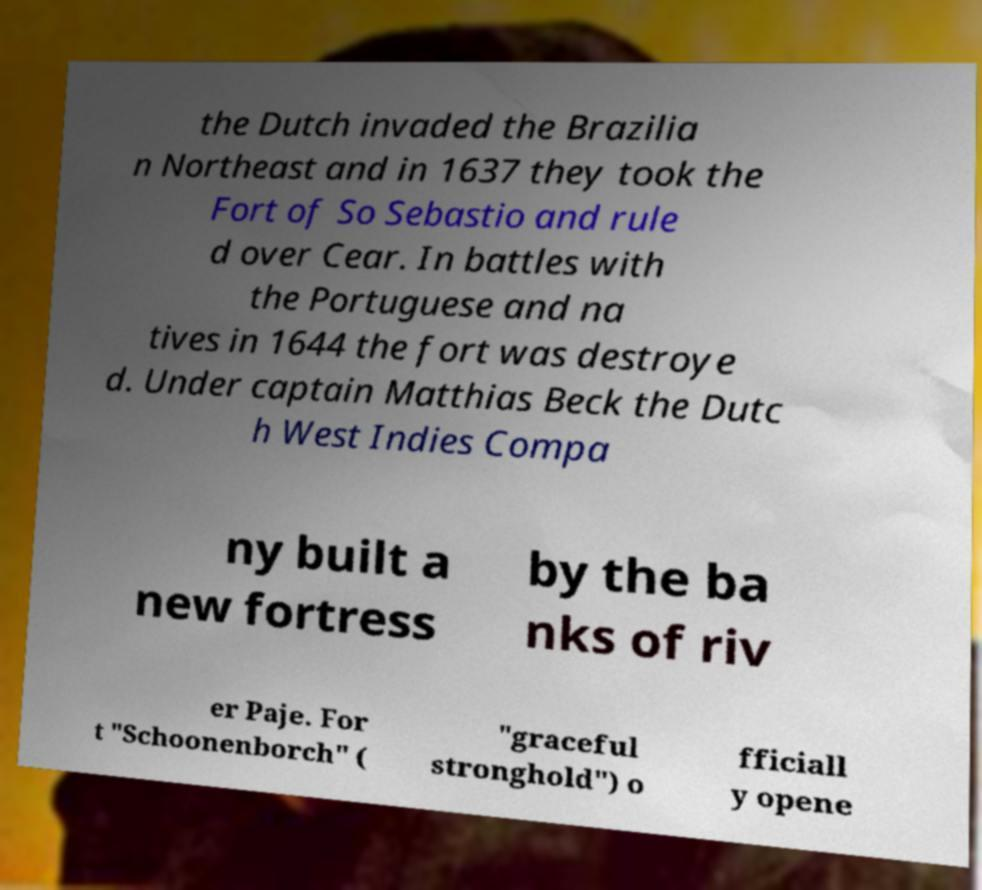Could you extract and type out the text from this image? the Dutch invaded the Brazilia n Northeast and in 1637 they took the Fort of So Sebastio and rule d over Cear. In battles with the Portuguese and na tives in 1644 the fort was destroye d. Under captain Matthias Beck the Dutc h West Indies Compa ny built a new fortress by the ba nks of riv er Paje. For t "Schoonenborch" ( "graceful stronghold") o fficiall y opene 